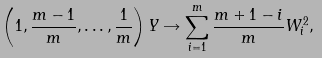Convert formula to latex. <formula><loc_0><loc_0><loc_500><loc_500>\left ( 1 , \frac { m - 1 } { m } , \dots , \frac { 1 } { m } \right ) Y \rightarrow \sum ^ { m } _ { i = 1 } \frac { m + 1 - i } { m } W ^ { 2 } _ { i } ,</formula> 